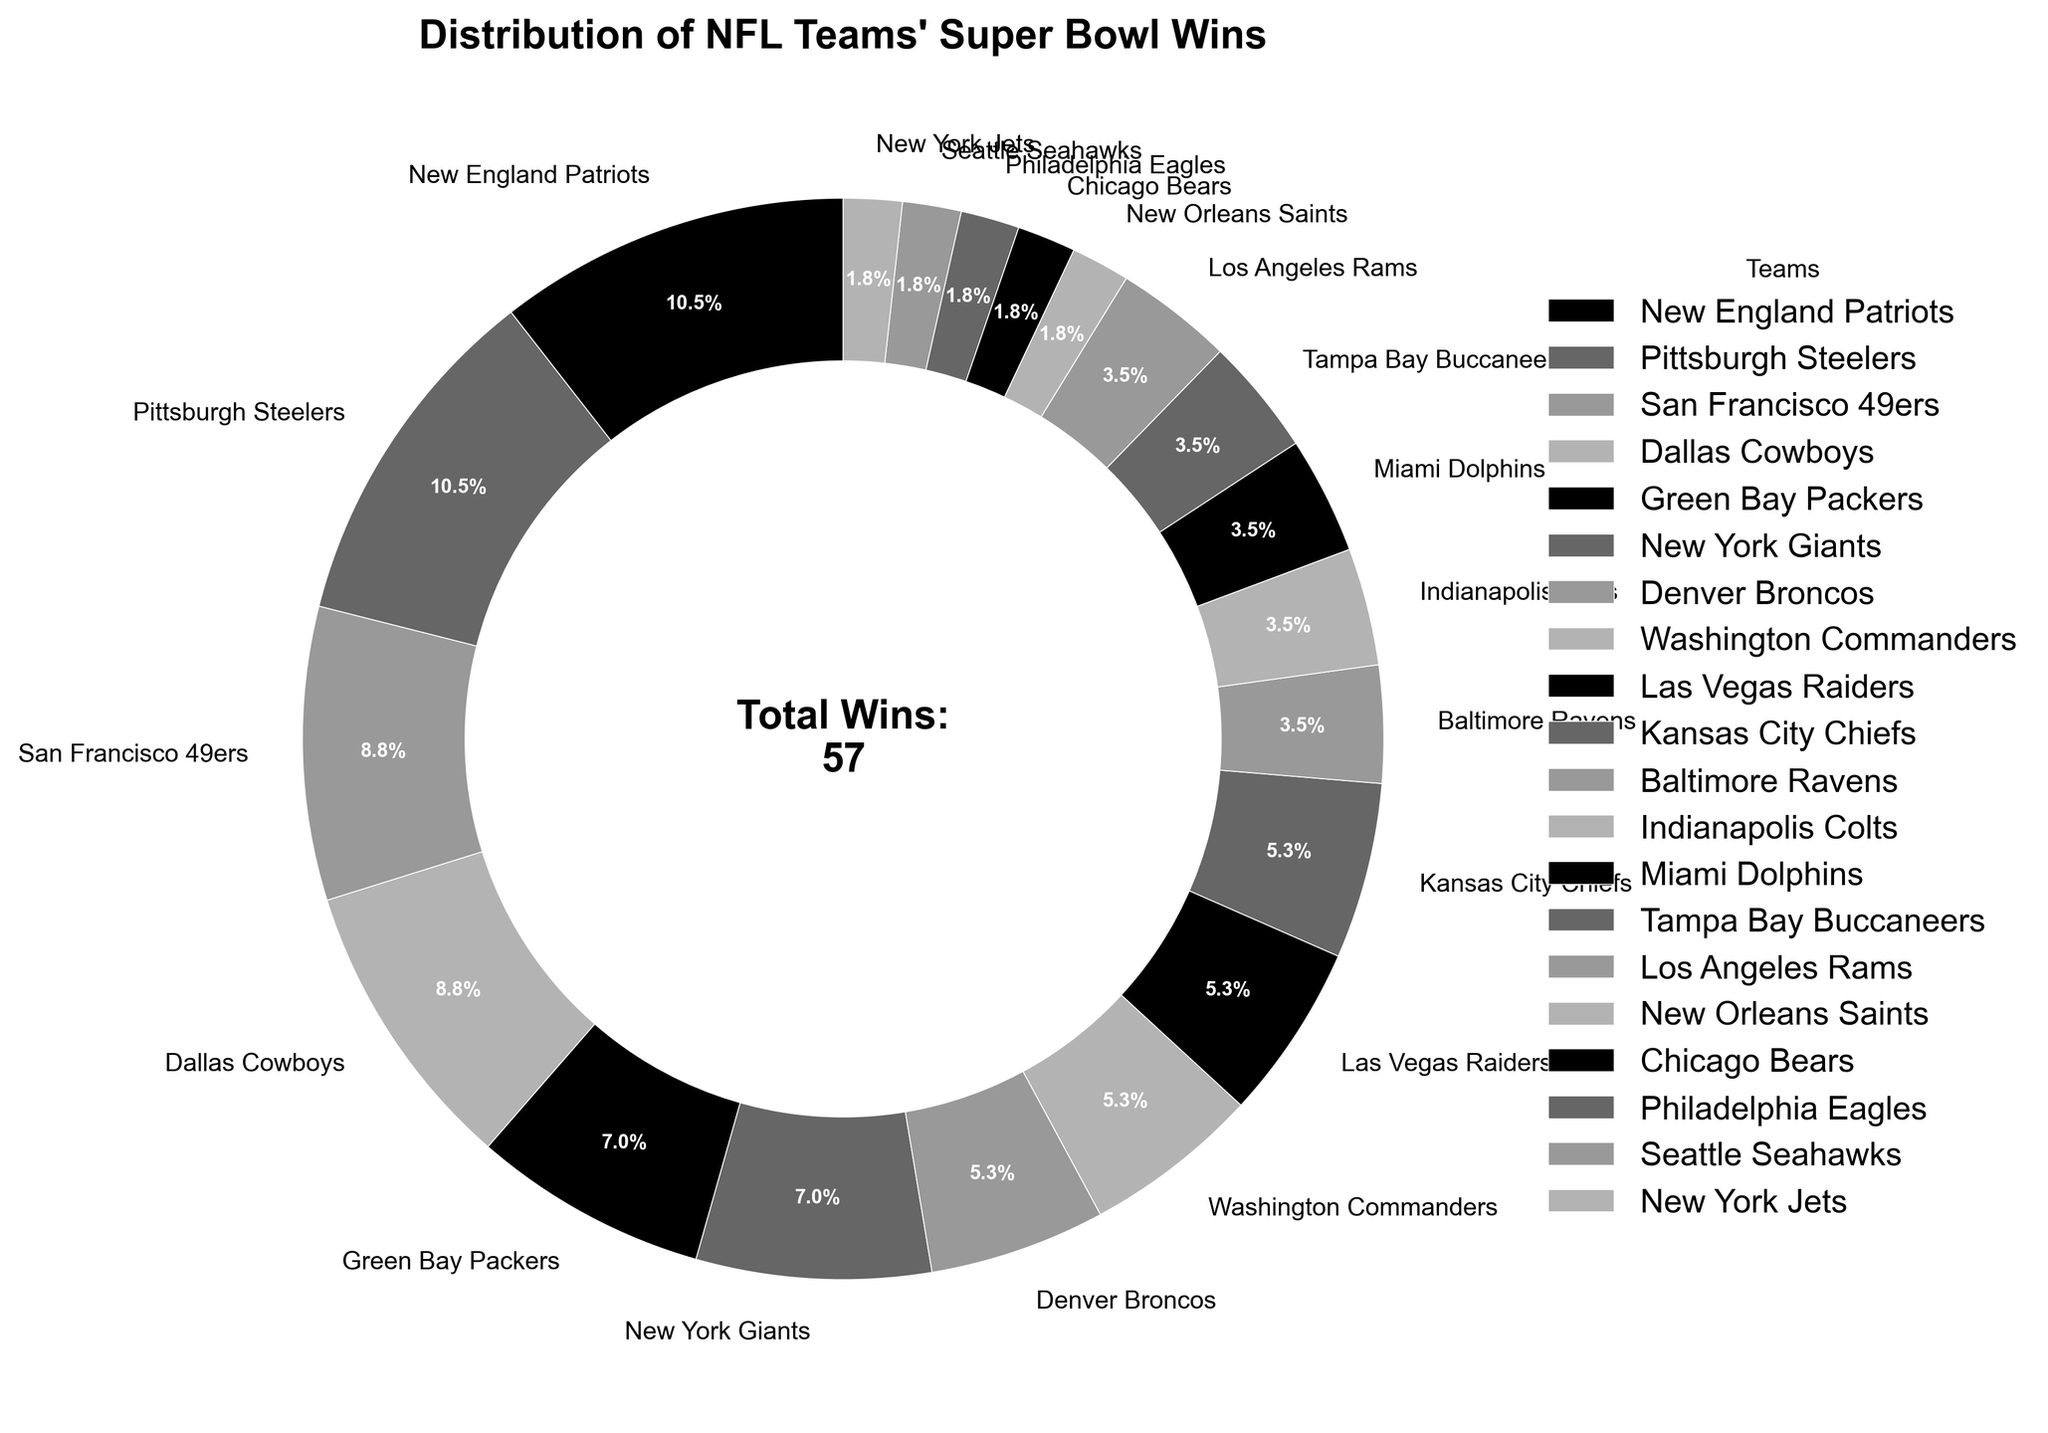What percentage of Super Bowl wins do the New England Patriots account for? The Patriots have 6 Super Bowl wins. To get the percentage, we need to divide the Patriots' wins by the total wins and multiply by 100. Total wins are 46 (sum of all wins in the figure), so (6/46) * 100 ≈ 13.0%.
Answer: 13.0% Which teams have an equal number of Super Bowl wins? By looking at the figure, the New England Patriots and Pittsburgh Steelers both have 6 wins, and the San Francisco 49ers and Dallas Cowboys both have 5 wins. Additionally, the Green Bay Packers and New York Giants have 4 wins each, and multiple teams have 3, 2, or 1 win each.
Answer: New England Patriots and Pittsburgh Steelers, San Francisco 49ers and Dallas Cowboys, Green Bay Packers and New York Giants How many teams have exactly 3 Super Bowl wins? The figure shows that the Denver Broncos, Washington Commanders, Las Vegas Raiders, and Kansas City Chiefs each have 3 wins. By counting these teams, we find there are 4 teams with exactly 3 wins.
Answer: 4 Which team has the smallest portion of Super Bowl wins? The figure has the portion sizes indicating the number of wins. The New Orleans Saints, Chicago Bears, Philadelphia Eagles, Seattle Seahawks, and New York Jets each have 1 win. Hence, they all share the smallest portion, which is equally small.
Answer: New Orleans Saints, Chicago Bears, Philadelphia Eagles, Seattle Seahawks, New York Jets Of the teams with more than 1 win, which team has the fewest Super Bowl wins? Looking at the figure, the teams with more than 1 win with the fewest wins are the Baltimore Ravens, Indianapolis Colts, Miami Dolphins, Tampa Bay Buccaneers, and Los Angeles Rams, each with 2 wins.
Answer: Baltimore Ravens, Indianapolis Colts, Miami Dolphins, Tampa Bay Buccaneers, Los Angeles Rams What is the combined percentage of total Super Bowl wins by the top two teams? The top two teams are the New England Patriots and Pittsburgh Steelers, each with 6 wins. Combined, they have 12 wins. To find the percentage, we calculate (12/46) * 100 ≈ 26.1%.
Answer: 26.1% Among the teams listed, which one has the most Super Bowl wins, and how many do they have? Both the New England Patriots and Pittsburgh Steelers have the most Super Bowl wins, each with 6.
Answer: New England Patriots and Pittsburgh Steelers, 6 wins What is the difference in the number of Super Bowl wins between the team with the most wins and the New Orleans Saints? The team with the most wins (New England Patriots and Pittsburgh Steelers) has 6 wins. The New Orleans Saints have 1 win. The difference is 6 - 1 = 5.
Answer: 5 How many more Super Bowl wins do the Dallas Cowboys have compared to the New Orleans Saints? The figure shows the Dallas Cowboys have 5 Super Bowl wins while the New Orleans Saints have 1. The difference is 5 - 1 = 4.
Answer: 4 What portion of wins do the San Francisco 49ers and Dallas Cowboys combined represent? The San Francisco 49ers and Dallas Cowboys each have 5 wins, combining for 10 wins. To find the portion, we calculate (10/46) * 100 ≈ 21.7%.
Answer: 21.7% 